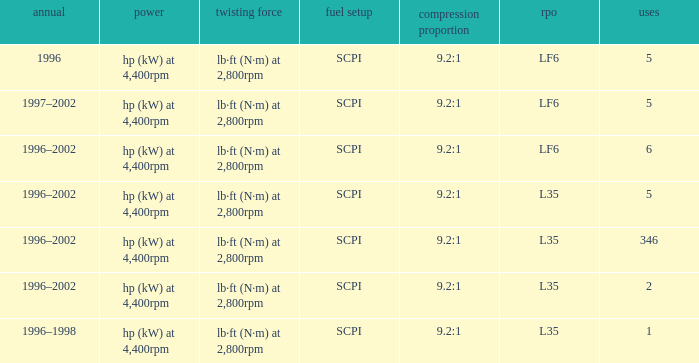What are the torque characteristics of the model made in 1996? Lb·ft (n·m) at 2,800rpm. 